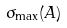Convert formula to latex. <formula><loc_0><loc_0><loc_500><loc_500>\sigma _ { \max } ( A )</formula> 